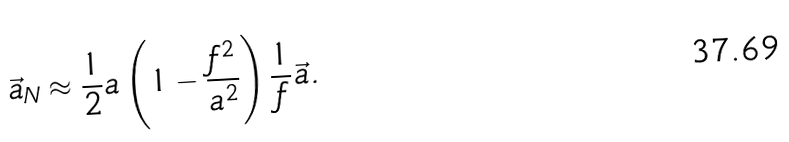Convert formula to latex. <formula><loc_0><loc_0><loc_500><loc_500>\vec { a } _ { N } \approx \frac { 1 } { 2 } a \left ( 1 - \frac { f ^ { 2 } } { a ^ { 2 } } \right ) \frac { 1 } { f } \vec { a } .</formula> 